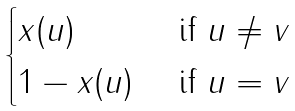<formula> <loc_0><loc_0><loc_500><loc_500>\begin{cases} x ( u ) & \text { if } u \not = v \\ 1 - x ( u ) & \text { if } u = v \end{cases}</formula> 